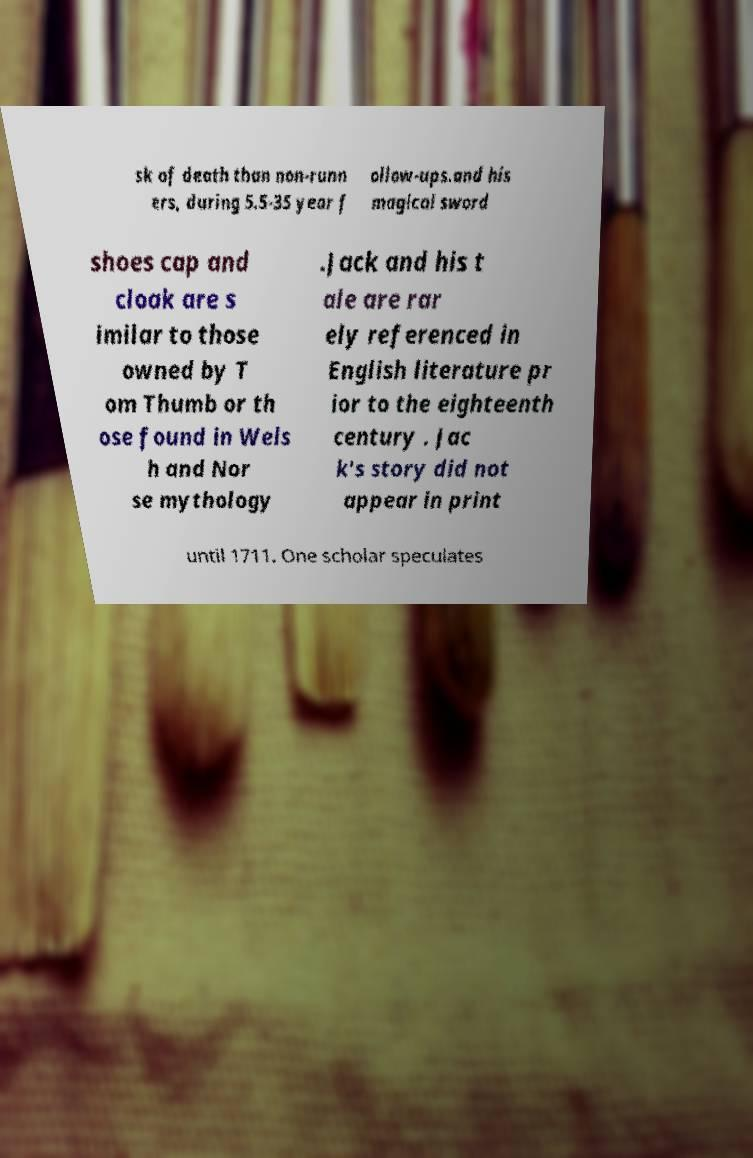For documentation purposes, I need the text within this image transcribed. Could you provide that? sk of death than non-runn ers, during 5.5-35 year f ollow-ups.and his magical sword shoes cap and cloak are s imilar to those owned by T om Thumb or th ose found in Wels h and Nor se mythology .Jack and his t ale are rar ely referenced in English literature pr ior to the eighteenth century . Jac k's story did not appear in print until 1711. One scholar speculates 